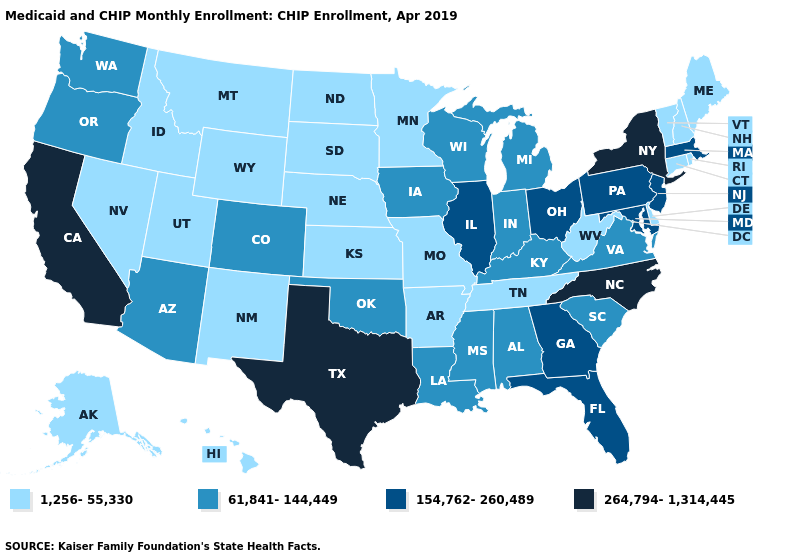What is the lowest value in states that border Arizona?
Short answer required. 1,256-55,330. What is the highest value in the MidWest ?
Concise answer only. 154,762-260,489. Does Maine have the same value as Connecticut?
Quick response, please. Yes. Name the states that have a value in the range 1,256-55,330?
Give a very brief answer. Alaska, Arkansas, Connecticut, Delaware, Hawaii, Idaho, Kansas, Maine, Minnesota, Missouri, Montana, Nebraska, Nevada, New Hampshire, New Mexico, North Dakota, Rhode Island, South Dakota, Tennessee, Utah, Vermont, West Virginia, Wyoming. What is the lowest value in the USA?
Answer briefly. 1,256-55,330. Among the states that border Oregon , does California have the highest value?
Be succinct. Yes. What is the value of Texas?
Give a very brief answer. 264,794-1,314,445. Which states have the highest value in the USA?
Write a very short answer. California, New York, North Carolina, Texas. Does the first symbol in the legend represent the smallest category?
Quick response, please. Yes. Name the states that have a value in the range 264,794-1,314,445?
Concise answer only. California, New York, North Carolina, Texas. What is the lowest value in the West?
Write a very short answer. 1,256-55,330. What is the highest value in the USA?
Write a very short answer. 264,794-1,314,445. Does the map have missing data?
Write a very short answer. No. Does Indiana have the lowest value in the MidWest?
Quick response, please. No. What is the value of New York?
Concise answer only. 264,794-1,314,445. 